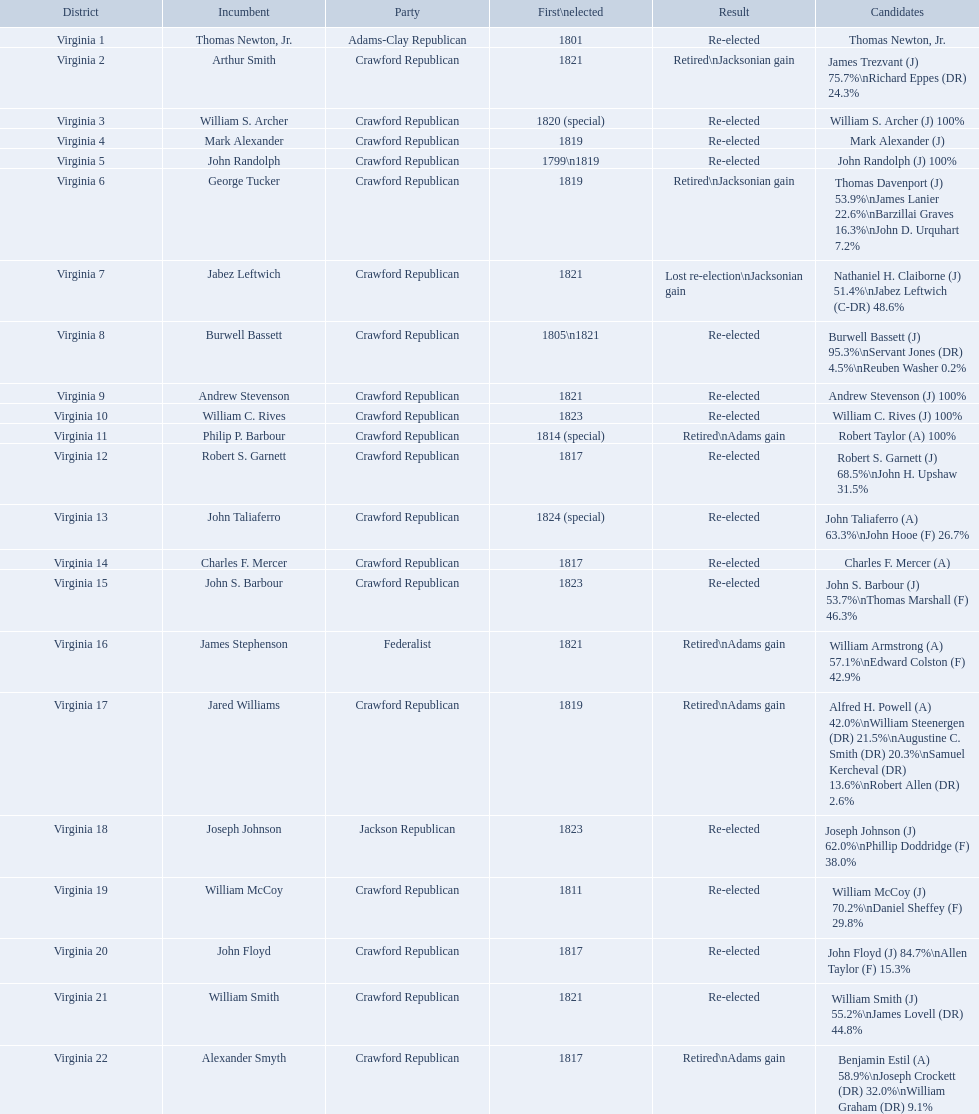Give me the full table as a dictionary. {'header': ['District', 'Incumbent', 'Party', 'First\\nelected', 'Result', 'Candidates'], 'rows': [['Virginia 1', 'Thomas Newton, Jr.', 'Adams-Clay Republican', '1801', 'Re-elected', 'Thomas Newton, Jr.'], ['Virginia 2', 'Arthur Smith', 'Crawford Republican', '1821', 'Retired\\nJacksonian gain', 'James Trezvant (J) 75.7%\\nRichard Eppes (DR) 24.3%'], ['Virginia 3', 'William S. Archer', 'Crawford Republican', '1820 (special)', 'Re-elected', 'William S. Archer (J) 100%'], ['Virginia 4', 'Mark Alexander', 'Crawford Republican', '1819', 'Re-elected', 'Mark Alexander (J)'], ['Virginia 5', 'John Randolph', 'Crawford Republican', '1799\\n1819', 'Re-elected', 'John Randolph (J) 100%'], ['Virginia 6', 'George Tucker', 'Crawford Republican', '1819', 'Retired\\nJacksonian gain', 'Thomas Davenport (J) 53.9%\\nJames Lanier 22.6%\\nBarzillai Graves 16.3%\\nJohn D. Urquhart 7.2%'], ['Virginia 7', 'Jabez Leftwich', 'Crawford Republican', '1821', 'Lost re-election\\nJacksonian gain', 'Nathaniel H. Claiborne (J) 51.4%\\nJabez Leftwich (C-DR) 48.6%'], ['Virginia 8', 'Burwell Bassett', 'Crawford Republican', '1805\\n1821', 'Re-elected', 'Burwell Bassett (J) 95.3%\\nServant Jones (DR) 4.5%\\nReuben Washer 0.2%'], ['Virginia 9', 'Andrew Stevenson', 'Crawford Republican', '1821', 'Re-elected', 'Andrew Stevenson (J) 100%'], ['Virginia 10', 'William C. Rives', 'Crawford Republican', '1823', 'Re-elected', 'William C. Rives (J) 100%'], ['Virginia 11', 'Philip P. Barbour', 'Crawford Republican', '1814 (special)', 'Retired\\nAdams gain', 'Robert Taylor (A) 100%'], ['Virginia 12', 'Robert S. Garnett', 'Crawford Republican', '1817', 'Re-elected', 'Robert S. Garnett (J) 68.5%\\nJohn H. Upshaw 31.5%'], ['Virginia 13', 'John Taliaferro', 'Crawford Republican', '1824 (special)', 'Re-elected', 'John Taliaferro (A) 63.3%\\nJohn Hooe (F) 26.7%'], ['Virginia 14', 'Charles F. Mercer', 'Crawford Republican', '1817', 'Re-elected', 'Charles F. Mercer (A)'], ['Virginia 15', 'John S. Barbour', 'Crawford Republican', '1823', 'Re-elected', 'John S. Barbour (J) 53.7%\\nThomas Marshall (F) 46.3%'], ['Virginia 16', 'James Stephenson', 'Federalist', '1821', 'Retired\\nAdams gain', 'William Armstrong (A) 57.1%\\nEdward Colston (F) 42.9%'], ['Virginia 17', 'Jared Williams', 'Crawford Republican', '1819', 'Retired\\nAdams gain', 'Alfred H. Powell (A) 42.0%\\nWilliam Steenergen (DR) 21.5%\\nAugustine C. Smith (DR) 20.3%\\nSamuel Kercheval (DR) 13.6%\\nRobert Allen (DR) 2.6%'], ['Virginia 18', 'Joseph Johnson', 'Jackson Republican', '1823', 'Re-elected', 'Joseph Johnson (J) 62.0%\\nPhillip Doddridge (F) 38.0%'], ['Virginia 19', 'William McCoy', 'Crawford Republican', '1811', 'Re-elected', 'William McCoy (J) 70.2%\\nDaniel Sheffey (F) 29.8%'], ['Virginia 20', 'John Floyd', 'Crawford Republican', '1817', 'Re-elected', 'John Floyd (J) 84.7%\\nAllen Taylor (F) 15.3%'], ['Virginia 21', 'William Smith', 'Crawford Republican', '1821', 'Re-elected', 'William Smith (J) 55.2%\\nJames Lovell (DR) 44.8%'], ['Virginia 22', 'Alexander Smyth', 'Crawford Republican', '1817', 'Retired\\nAdams gain', 'Benjamin Estil (A) 58.9%\\nJoseph Crockett (DR) 32.0%\\nWilliam Graham (DR) 9.1%']]} Who were the incumbents of the 1824 united states house of representatives elections? Thomas Newton, Jr., Arthur Smith, William S. Archer, Mark Alexander, John Randolph, George Tucker, Jabez Leftwich, Burwell Bassett, Andrew Stevenson, William C. Rives, Philip P. Barbour, Robert S. Garnett, John Taliaferro, Charles F. Mercer, John S. Barbour, James Stephenson, Jared Williams, Joseph Johnson, William McCoy, John Floyd, William Smith, Alexander Smyth. And who were the candidates? Thomas Newton, Jr., James Trezvant (J) 75.7%\nRichard Eppes (DR) 24.3%, William S. Archer (J) 100%, Mark Alexander (J), John Randolph (J) 100%, Thomas Davenport (J) 53.9%\nJames Lanier 22.6%\nBarzillai Graves 16.3%\nJohn D. Urquhart 7.2%, Nathaniel H. Claiborne (J) 51.4%\nJabez Leftwich (C-DR) 48.6%, Burwell Bassett (J) 95.3%\nServant Jones (DR) 4.5%\nReuben Washer 0.2%, Andrew Stevenson (J) 100%, William C. Rives (J) 100%, Robert Taylor (A) 100%, Robert S. Garnett (J) 68.5%\nJohn H. Upshaw 31.5%, John Taliaferro (A) 63.3%\nJohn Hooe (F) 26.7%, Charles F. Mercer (A), John S. Barbour (J) 53.7%\nThomas Marshall (F) 46.3%, William Armstrong (A) 57.1%\nEdward Colston (F) 42.9%, Alfred H. Powell (A) 42.0%\nWilliam Steenergen (DR) 21.5%\nAugustine C. Smith (DR) 20.3%\nSamuel Kercheval (DR) 13.6%\nRobert Allen (DR) 2.6%, Joseph Johnson (J) 62.0%\nPhillip Doddridge (F) 38.0%, William McCoy (J) 70.2%\nDaniel Sheffey (F) 29.8%, John Floyd (J) 84.7%\nAllen Taylor (F) 15.3%, William Smith (J) 55.2%\nJames Lovell (DR) 44.8%, Benjamin Estil (A) 58.9%\nJoseph Crockett (DR) 32.0%\nWilliam Graham (DR) 9.1%. What were the results of their elections? Re-elected, Retired\nJacksonian gain, Re-elected, Re-elected, Re-elected, Retired\nJacksonian gain, Lost re-election\nJacksonian gain, Re-elected, Re-elected, Re-elected, Retired\nAdams gain, Re-elected, Re-elected, Re-elected, Re-elected, Retired\nAdams gain, Retired\nAdams gain, Re-elected, Re-elected, Re-elected, Re-elected, Retired\nAdams gain. And which jacksonian won over 76%? Arthur Smith. What party is a crawford republican? Crawford Republican, Crawford Republican, Crawford Republican, Crawford Republican, Crawford Republican, Crawford Republican, Crawford Republican, Crawford Republican, Crawford Republican, Crawford Republican, Crawford Republican, Crawford Republican, Crawford Republican, Crawford Republican, Crawford Republican, Crawford Republican, Crawford Republican, Crawford Republican, Crawford Republican. What candidates have over 76%? James Trezvant (J) 75.7%\nRichard Eppes (DR) 24.3%, William S. Archer (J) 100%, John Randolph (J) 100%, Burwell Bassett (J) 95.3%\nServant Jones (DR) 4.5%\nReuben Washer 0.2%, Andrew Stevenson (J) 100%, William C. Rives (J) 100%, Robert Taylor (A) 100%, John Floyd (J) 84.7%\nAllen Taylor (F) 15.3%. Which result was retired jacksonian gain? Retired\nJacksonian gain. Who was the incumbent? Arthur Smith. Which group does a crawford republican belong to? Crawford Republican, Crawford Republican, Crawford Republican, Crawford Republican, Crawford Republican, Crawford Republican, Crawford Republican, Crawford Republican, Crawford Republican, Crawford Republican, Crawford Republican, Crawford Republican, Crawford Republican, Crawford Republican, Crawford Republican, Crawford Republican, Crawford Republican, Crawford Republican, Crawford Republican. Which contenders have more than 76%? James Trezvant (J) 75.7%\nRichard Eppes (DR) 24.3%, William S. Archer (J) 100%, John Randolph (J) 100%, Burwell Bassett (J) 95.3%\nServant Jones (DR) 4.5%\nReuben Washer 0.2%, Andrew Stevenson (J) 100%, William C. Rives (J) 100%, Robert Taylor (A) 100%, John Floyd (J) 84.7%\nAllen Taylor (F) 15.3%. What outcome was achieved by a retired jacksonian gain? Retired\nJacksonian gain. Who held the position before? Arthur Smith. Could you help me parse every detail presented in this table? {'header': ['District', 'Incumbent', 'Party', 'First\\nelected', 'Result', 'Candidates'], 'rows': [['Virginia 1', 'Thomas Newton, Jr.', 'Adams-Clay Republican', '1801', 'Re-elected', 'Thomas Newton, Jr.'], ['Virginia 2', 'Arthur Smith', 'Crawford Republican', '1821', 'Retired\\nJacksonian gain', 'James Trezvant (J) 75.7%\\nRichard Eppes (DR) 24.3%'], ['Virginia 3', 'William S. Archer', 'Crawford Republican', '1820 (special)', 'Re-elected', 'William S. Archer (J) 100%'], ['Virginia 4', 'Mark Alexander', 'Crawford Republican', '1819', 'Re-elected', 'Mark Alexander (J)'], ['Virginia 5', 'John Randolph', 'Crawford Republican', '1799\\n1819', 'Re-elected', 'John Randolph (J) 100%'], ['Virginia 6', 'George Tucker', 'Crawford Republican', '1819', 'Retired\\nJacksonian gain', 'Thomas Davenport (J) 53.9%\\nJames Lanier 22.6%\\nBarzillai Graves 16.3%\\nJohn D. Urquhart 7.2%'], ['Virginia 7', 'Jabez Leftwich', 'Crawford Republican', '1821', 'Lost re-election\\nJacksonian gain', 'Nathaniel H. Claiborne (J) 51.4%\\nJabez Leftwich (C-DR) 48.6%'], ['Virginia 8', 'Burwell Bassett', 'Crawford Republican', '1805\\n1821', 'Re-elected', 'Burwell Bassett (J) 95.3%\\nServant Jones (DR) 4.5%\\nReuben Washer 0.2%'], ['Virginia 9', 'Andrew Stevenson', 'Crawford Republican', '1821', 'Re-elected', 'Andrew Stevenson (J) 100%'], ['Virginia 10', 'William C. Rives', 'Crawford Republican', '1823', 'Re-elected', 'William C. Rives (J) 100%'], ['Virginia 11', 'Philip P. Barbour', 'Crawford Republican', '1814 (special)', 'Retired\\nAdams gain', 'Robert Taylor (A) 100%'], ['Virginia 12', 'Robert S. Garnett', 'Crawford Republican', '1817', 'Re-elected', 'Robert S. Garnett (J) 68.5%\\nJohn H. Upshaw 31.5%'], ['Virginia 13', 'John Taliaferro', 'Crawford Republican', '1824 (special)', 'Re-elected', 'John Taliaferro (A) 63.3%\\nJohn Hooe (F) 26.7%'], ['Virginia 14', 'Charles F. Mercer', 'Crawford Republican', '1817', 'Re-elected', 'Charles F. Mercer (A)'], ['Virginia 15', 'John S. Barbour', 'Crawford Republican', '1823', 'Re-elected', 'John S. Barbour (J) 53.7%\\nThomas Marshall (F) 46.3%'], ['Virginia 16', 'James Stephenson', 'Federalist', '1821', 'Retired\\nAdams gain', 'William Armstrong (A) 57.1%\\nEdward Colston (F) 42.9%'], ['Virginia 17', 'Jared Williams', 'Crawford Republican', '1819', 'Retired\\nAdams gain', 'Alfred H. Powell (A) 42.0%\\nWilliam Steenergen (DR) 21.5%\\nAugustine C. Smith (DR) 20.3%\\nSamuel Kercheval (DR) 13.6%\\nRobert Allen (DR) 2.6%'], ['Virginia 18', 'Joseph Johnson', 'Jackson Republican', '1823', 'Re-elected', 'Joseph Johnson (J) 62.0%\\nPhillip Doddridge (F) 38.0%'], ['Virginia 19', 'William McCoy', 'Crawford Republican', '1811', 'Re-elected', 'William McCoy (J) 70.2%\\nDaniel Sheffey (F) 29.8%'], ['Virginia 20', 'John Floyd', 'Crawford Republican', '1817', 'Re-elected', 'John Floyd (J) 84.7%\\nAllen Taylor (F) 15.3%'], ['Virginia 21', 'William Smith', 'Crawford Republican', '1821', 'Re-elected', 'William Smith (J) 55.2%\\nJames Lovell (DR) 44.8%'], ['Virginia 22', 'Alexander Smyth', 'Crawford Republican', '1817', 'Retired\\nAdams gain', 'Benjamin Estil (A) 58.9%\\nJoseph Crockett (DR) 32.0%\\nWilliam Graham (DR) 9.1%']]} To which party does a crawford republican pertain? Crawford Republican, Crawford Republican, Crawford Republican, Crawford Republican, Crawford Republican, Crawford Republican, Crawford Republican, Crawford Republican, Crawford Republican, Crawford Republican, Crawford Republican, Crawford Republican, Crawford Republican, Crawford Republican, Crawford Republican, Crawford Republican, Crawford Republican, Crawford Republican, Crawford Republican. Which nominees possess above 76%? James Trezvant (J) 75.7%\nRichard Eppes (DR) 24.3%, William S. Archer (J) 100%, John Randolph (J) 100%, Burwell Bassett (J) 95.3%\nServant Jones (DR) 4.5%\nReuben Washer 0.2%, Andrew Stevenson (J) 100%, William C. Rives (J) 100%, Robert Taylor (A) 100%, John Floyd (J) 84.7%\nAllen Taylor (F) 15.3%. What was the consequence of the retired jacksonian gain? Retired\nJacksonian gain. Who was the previous officeholder? Arthur Smith. What faction does a crawford republican associate with? Crawford Republican, Crawford Republican, Crawford Republican, Crawford Republican, Crawford Republican, Crawford Republican, Crawford Republican, Crawford Republican, Crawford Republican, Crawford Republican, Crawford Republican, Crawford Republican, Crawford Republican, Crawford Republican, Crawford Republican, Crawford Republican, Crawford Republican, Crawford Republican, Crawford Republican. Which candidates hold a percentage exceeding 76%? James Trezvant (J) 75.7%\nRichard Eppes (DR) 24.3%, William S. Archer (J) 100%, John Randolph (J) 100%, Burwell Bassett (J) 95.3%\nServant Jones (DR) 4.5%\nReuben Washer 0.2%, Andrew Stevenson (J) 100%, William C. Rives (J) 100%, Robert Taylor (A) 100%, John Floyd (J) 84.7%\nAllen Taylor (F) 15.3%. What was the effect of the retired jacksonian gain? Retired\nJacksonian gain. Who was the incumbent prior? Arthur Smith. 